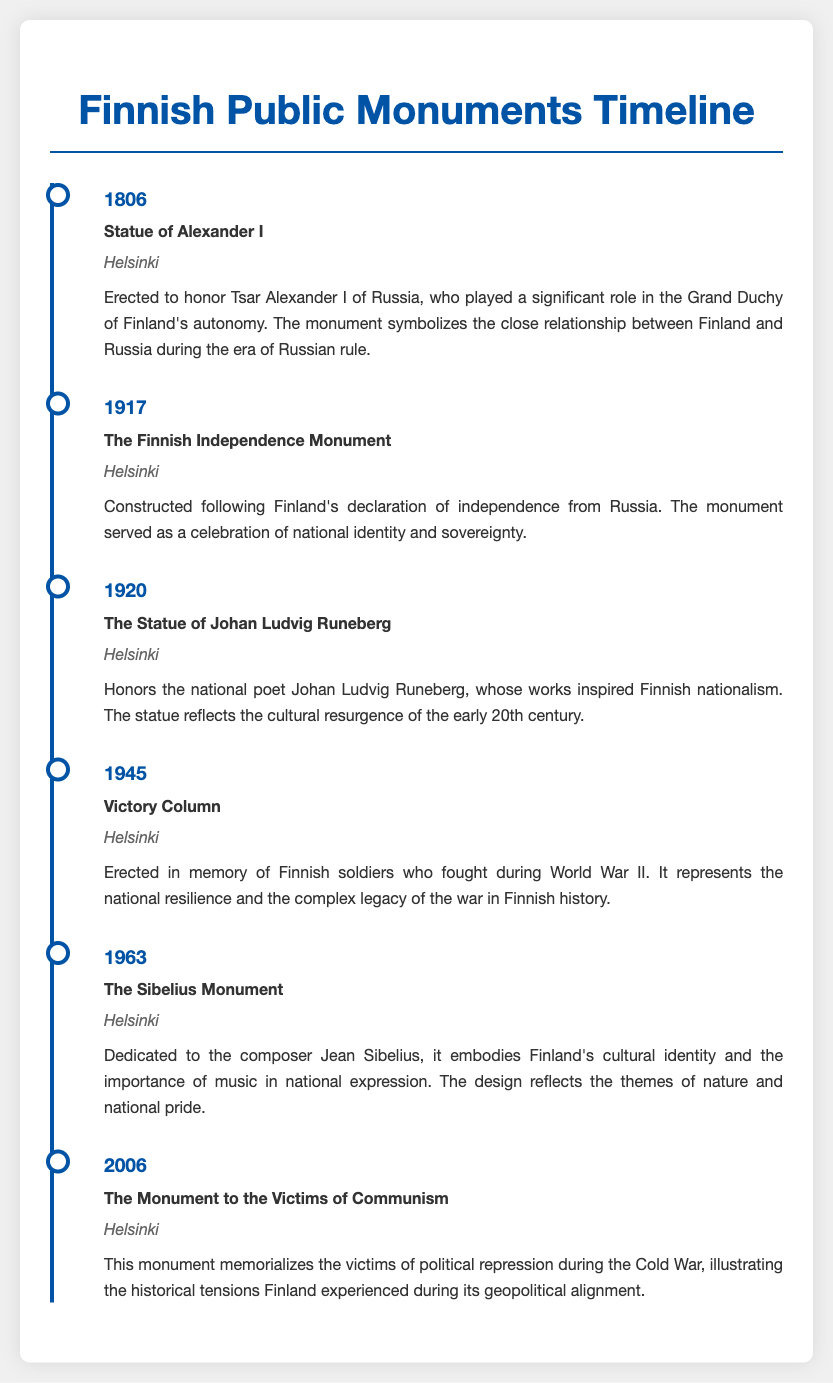What year was the Statue of Alexander I erected? The document states the Statue of Alexander I was erected in 1806.
Answer: 1806 What is the significance of the Finnish Independence Monument? According to the document, it celebrates national identity and sovereignty following Finland's declaration of independence from Russia.
Answer: National identity and sovereignty Which monument honors the national poet Johan Ludvig Runeberg? The document mentions the Statue of Johan Ludvig Runeberg as the monument that honors him.
Answer: Statue of Johan Ludvig Runeberg What event does the Victory Column commemorate? The document indicates that the Victory Column commemorates Finnish soldiers who fought during World War II.
Answer: Finnish soldiers in World War II How many years are there between the Sibelius Monument and the Monument to the Victims of Communism? The document shows the Sibelius Monument was completed in 1963 and the monument to the victims of Communism in 2006, making a difference of 43 years.
Answer: 43 years What role did Tsar Alexander I play in Finnish history? The document highlights that he played a significant role in the Grand Duchy of Finland's autonomy.
Answer: Grand Duchy of Finland's autonomy What recurring theme is reflected in the design of the Sibelius Monument? The document notes that the design reflects themes of nature and national pride.
Answer: Nature and national pride Where is the Monument to the Victims of Communism located? The document specifies that the Monument to the Victims of Communism is located in Helsinki.
Answer: Helsinki 